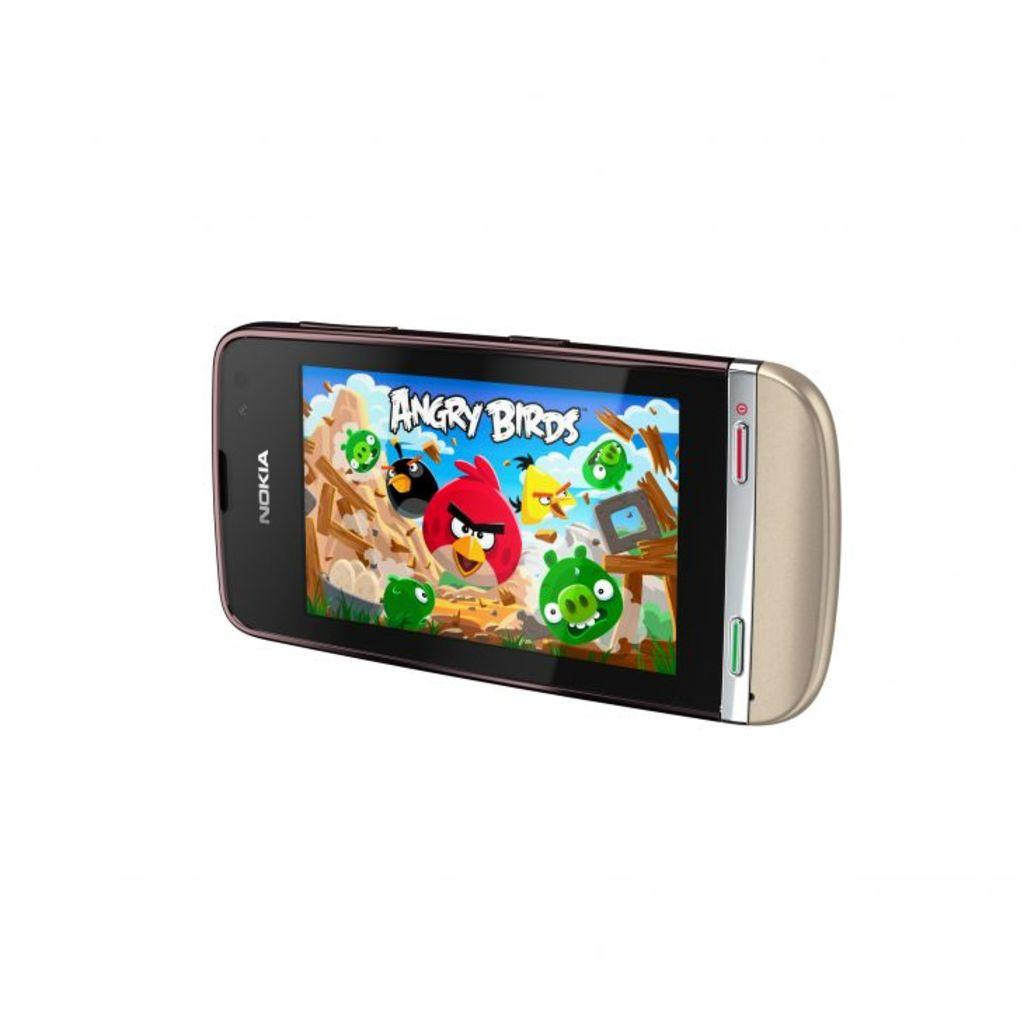<image>
Provide a brief description of the given image. A Nokia phone has a game of Angry Birds on the screen. 